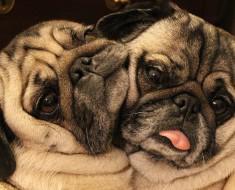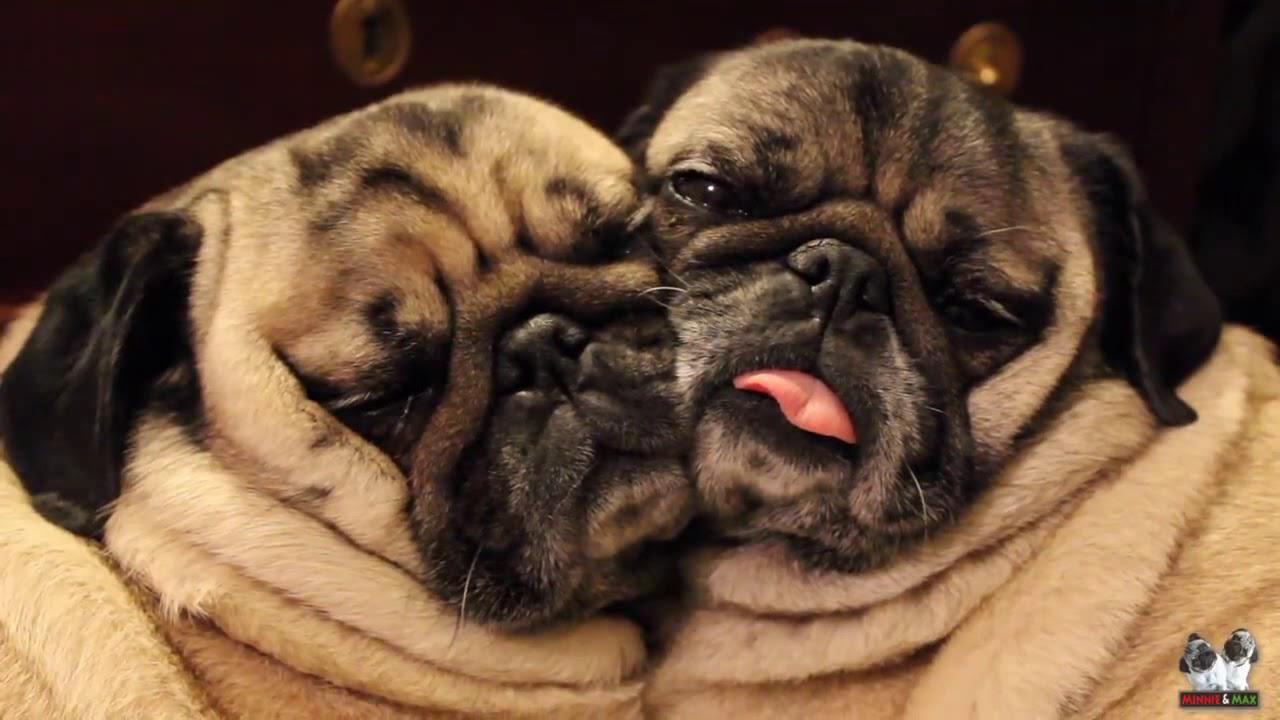The first image is the image on the left, the second image is the image on the right. Analyze the images presented: Is the assertion "a single pug is sleeping with it's tongue sticking out" valid? Answer yes or no. No. The first image is the image on the left, the second image is the image on the right. Assess this claim about the two images: "One image shows pugs sleeping side-by-side on something plush, and the other image shows one sleeping pug with its tongue hanging out.". Correct or not? Answer yes or no. No. 